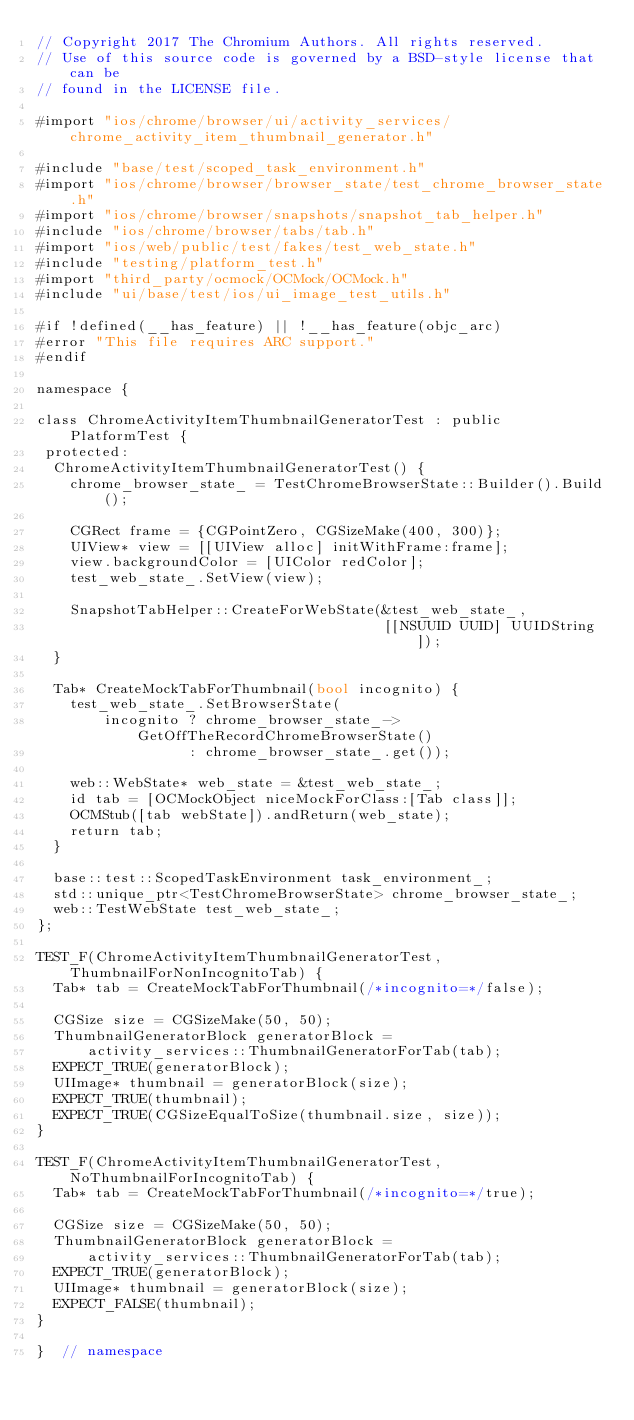Convert code to text. <code><loc_0><loc_0><loc_500><loc_500><_ObjectiveC_>// Copyright 2017 The Chromium Authors. All rights reserved.
// Use of this source code is governed by a BSD-style license that can be
// found in the LICENSE file.

#import "ios/chrome/browser/ui/activity_services/chrome_activity_item_thumbnail_generator.h"

#include "base/test/scoped_task_environment.h"
#import "ios/chrome/browser/browser_state/test_chrome_browser_state.h"
#import "ios/chrome/browser/snapshots/snapshot_tab_helper.h"
#include "ios/chrome/browser/tabs/tab.h"
#import "ios/web/public/test/fakes/test_web_state.h"
#include "testing/platform_test.h"
#import "third_party/ocmock/OCMock/OCMock.h"
#include "ui/base/test/ios/ui_image_test_utils.h"

#if !defined(__has_feature) || !__has_feature(objc_arc)
#error "This file requires ARC support."
#endif

namespace {

class ChromeActivityItemThumbnailGeneratorTest : public PlatformTest {
 protected:
  ChromeActivityItemThumbnailGeneratorTest() {
    chrome_browser_state_ = TestChromeBrowserState::Builder().Build();

    CGRect frame = {CGPointZero, CGSizeMake(400, 300)};
    UIView* view = [[UIView alloc] initWithFrame:frame];
    view.backgroundColor = [UIColor redColor];
    test_web_state_.SetView(view);

    SnapshotTabHelper::CreateForWebState(&test_web_state_,
                                         [[NSUUID UUID] UUIDString]);
  }

  Tab* CreateMockTabForThumbnail(bool incognito) {
    test_web_state_.SetBrowserState(
        incognito ? chrome_browser_state_->GetOffTheRecordChromeBrowserState()
                  : chrome_browser_state_.get());

    web::WebState* web_state = &test_web_state_;
    id tab = [OCMockObject niceMockForClass:[Tab class]];
    OCMStub([tab webState]).andReturn(web_state);
    return tab;
  }

  base::test::ScopedTaskEnvironment task_environment_;
  std::unique_ptr<TestChromeBrowserState> chrome_browser_state_;
  web::TestWebState test_web_state_;
};

TEST_F(ChromeActivityItemThumbnailGeneratorTest, ThumbnailForNonIncognitoTab) {
  Tab* tab = CreateMockTabForThumbnail(/*incognito=*/false);

  CGSize size = CGSizeMake(50, 50);
  ThumbnailGeneratorBlock generatorBlock =
      activity_services::ThumbnailGeneratorForTab(tab);
  EXPECT_TRUE(generatorBlock);
  UIImage* thumbnail = generatorBlock(size);
  EXPECT_TRUE(thumbnail);
  EXPECT_TRUE(CGSizeEqualToSize(thumbnail.size, size));
}

TEST_F(ChromeActivityItemThumbnailGeneratorTest, NoThumbnailForIncognitoTab) {
  Tab* tab = CreateMockTabForThumbnail(/*incognito=*/true);

  CGSize size = CGSizeMake(50, 50);
  ThumbnailGeneratorBlock generatorBlock =
      activity_services::ThumbnailGeneratorForTab(tab);
  EXPECT_TRUE(generatorBlock);
  UIImage* thumbnail = generatorBlock(size);
  EXPECT_FALSE(thumbnail);
}

}  // namespace
</code> 